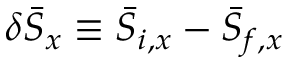<formula> <loc_0><loc_0><loc_500><loc_500>\delta { \bar { S } } _ { x } \equiv \bar { S } _ { i , x } - \bar { S } _ { f , x }</formula> 